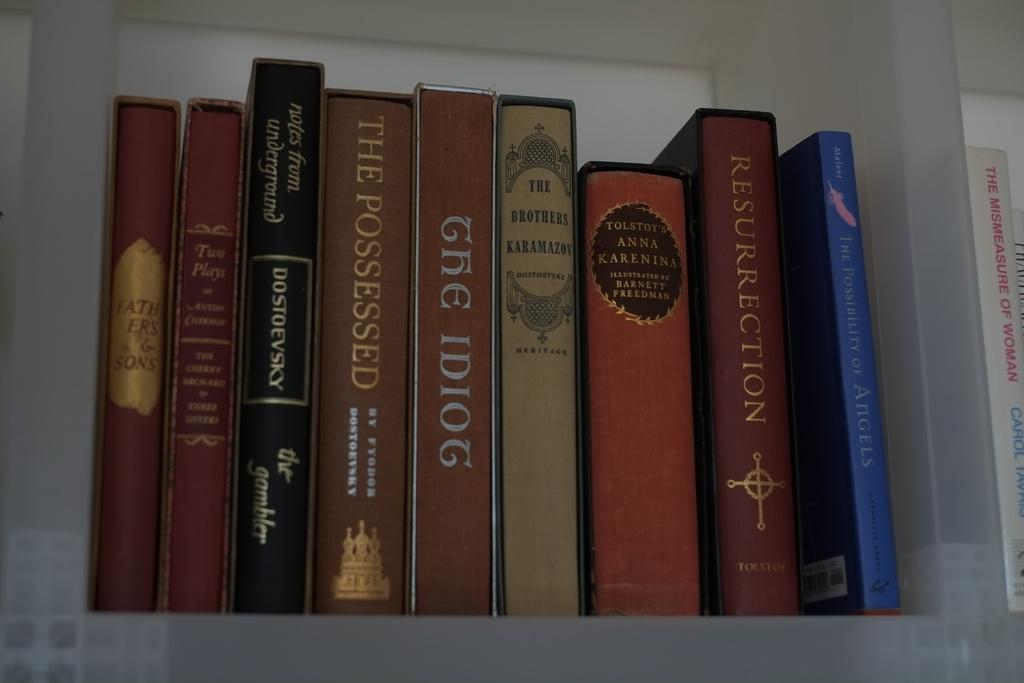<image>
Write a terse but informative summary of the picture. Nine books grouped together, with one being titled The Possessed. 